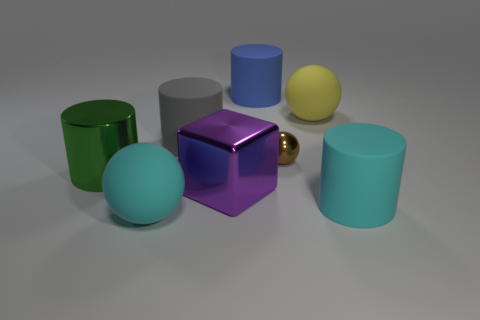Are there any other things that are the same size as the brown shiny ball?
Offer a terse response. No. There is a gray cylinder that is made of the same material as the cyan cylinder; what size is it?
Provide a short and direct response. Large. What number of other metal things are the same shape as the purple object?
Provide a short and direct response. 0. How many things are either shiny things that are on the right side of the blue matte cylinder or things that are in front of the big green metal cylinder?
Provide a succinct answer. 4. There is a cylinder that is on the right side of the brown metallic ball; what number of metallic cubes are behind it?
Offer a very short reply. 1. Is the shape of the big metal thing to the right of the green cylinder the same as the cyan object that is on the right side of the purple metal thing?
Provide a succinct answer. No. Are there any cyan spheres made of the same material as the brown thing?
Offer a very short reply. No. What number of metal things are either large green objects or blue blocks?
Your answer should be very brief. 1. There is a cyan thing on the right side of the tiny thing that is right of the purple cube; what shape is it?
Your answer should be very brief. Cylinder. Are there fewer large green metallic things to the right of the tiny brown sphere than large cyan spheres?
Your answer should be very brief. Yes. 